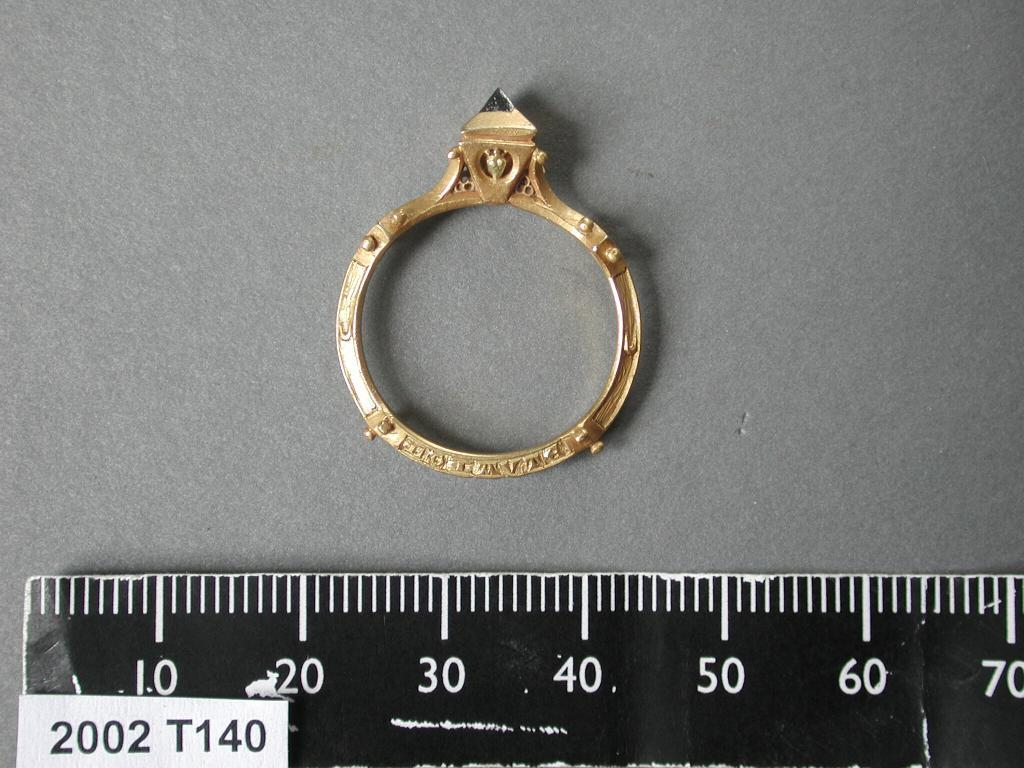<image>
Offer a succinct explanation of the picture presented. A ring measured by a ruler with 2002 T140 at the bottom. 